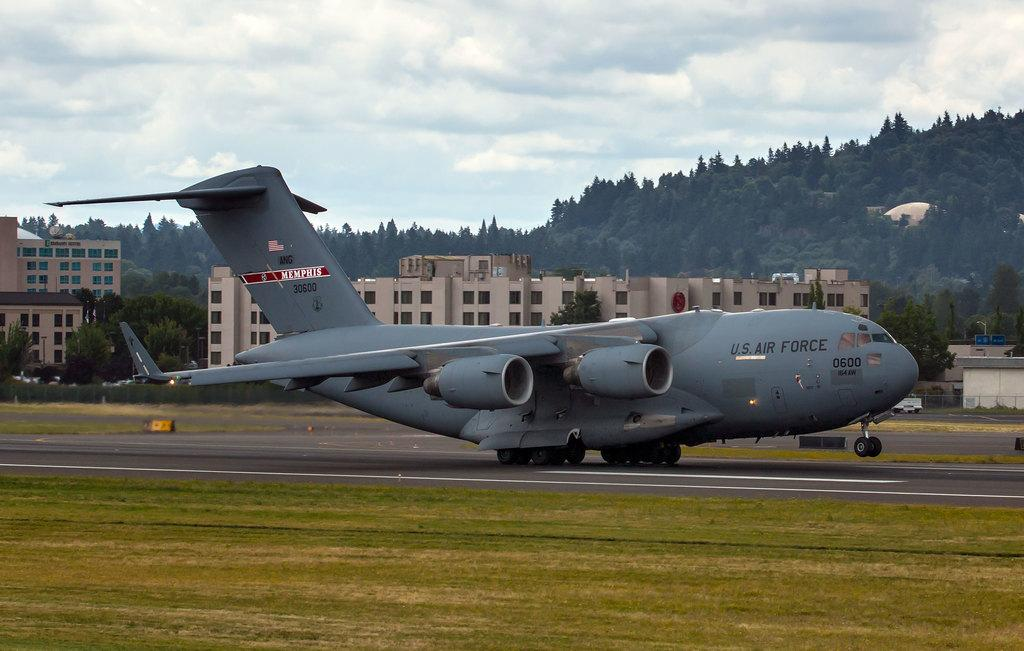Provide a one-sentence caption for the provided image. the words air force are on the side of a plane. 